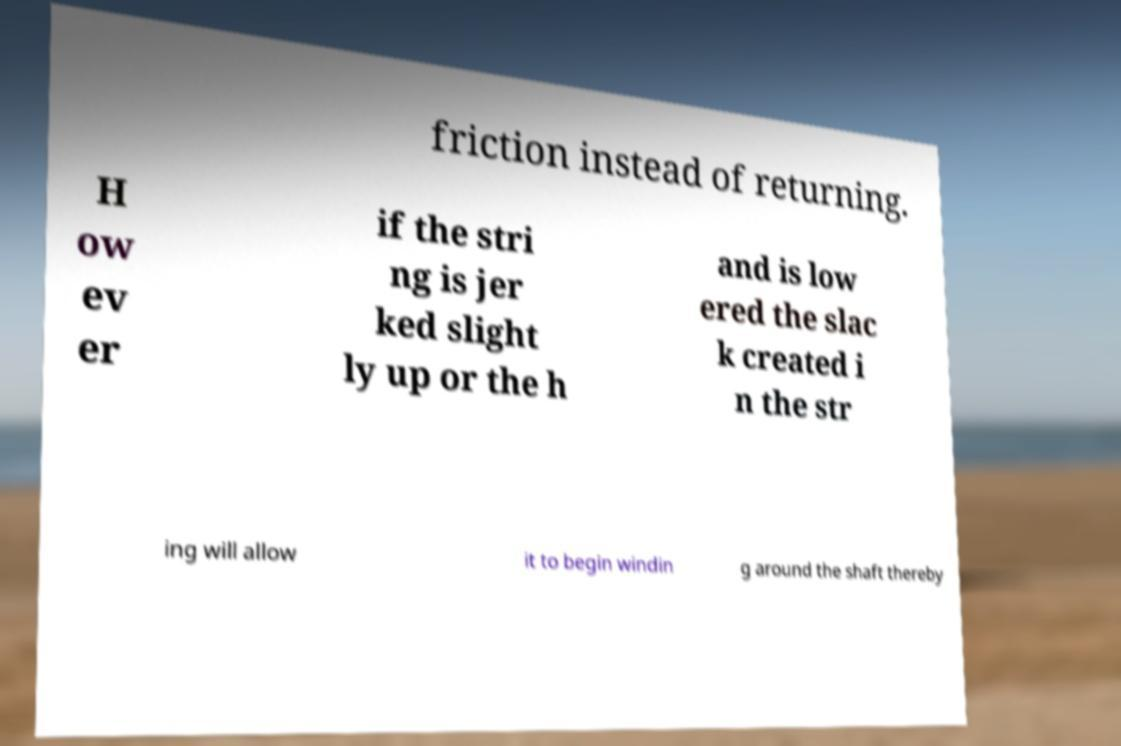I need the written content from this picture converted into text. Can you do that? friction instead of returning. H ow ev er if the stri ng is jer ked slight ly up or the h and is low ered the slac k created i n the str ing will allow it to begin windin g around the shaft thereby 